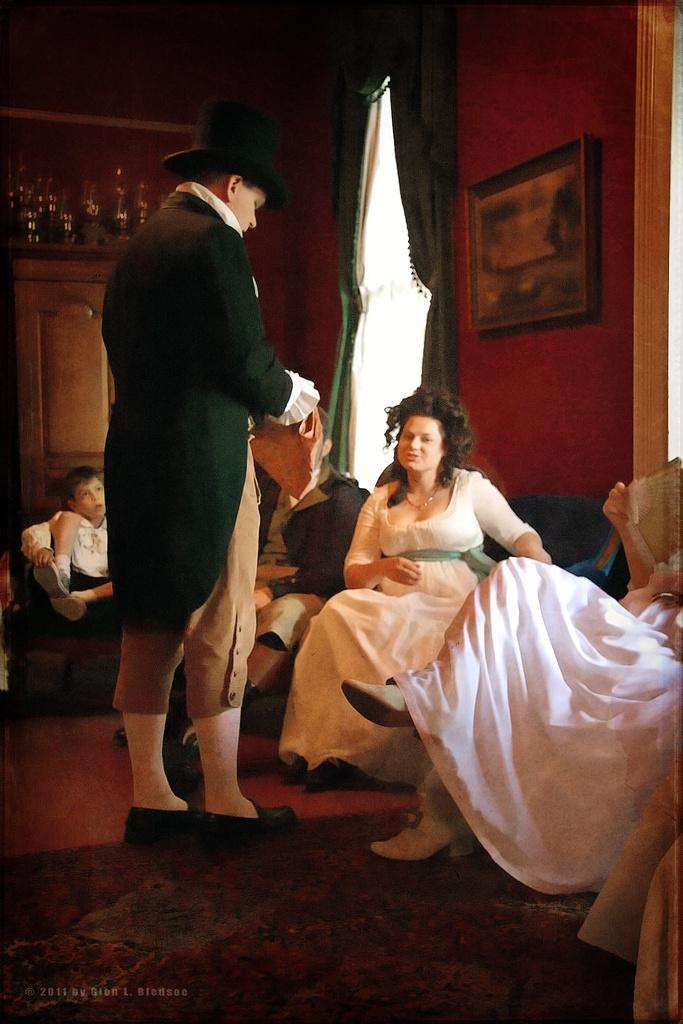Can you describe this image briefly? This picture is clicked inside. On the left there is a person holding an object and standing on the ground. On the right we can see the group of people sitting on the sofas. In the background we can see the curtains, picture frame hanging on the wall, wooden cabinet and some other objects. At the bottom left corner there is a text on the image. 